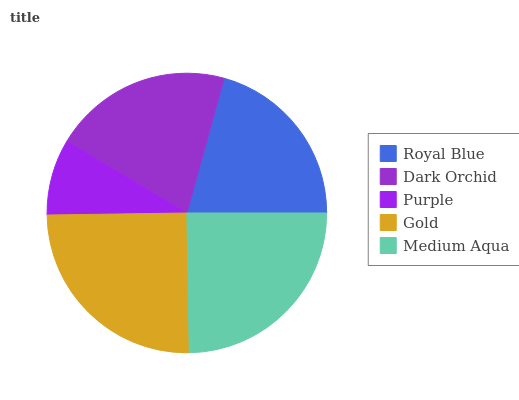Is Purple the minimum?
Answer yes or no. Yes. Is Gold the maximum?
Answer yes or no. Yes. Is Dark Orchid the minimum?
Answer yes or no. No. Is Dark Orchid the maximum?
Answer yes or no. No. Is Royal Blue greater than Dark Orchid?
Answer yes or no. Yes. Is Dark Orchid less than Royal Blue?
Answer yes or no. Yes. Is Dark Orchid greater than Royal Blue?
Answer yes or no. No. Is Royal Blue less than Dark Orchid?
Answer yes or no. No. Is Royal Blue the high median?
Answer yes or no. Yes. Is Royal Blue the low median?
Answer yes or no. Yes. Is Dark Orchid the high median?
Answer yes or no. No. Is Medium Aqua the low median?
Answer yes or no. No. 